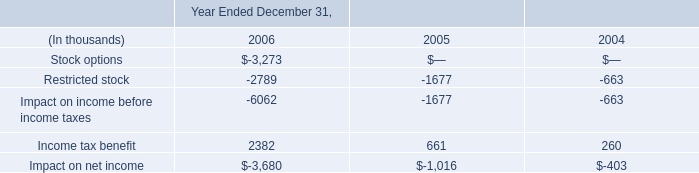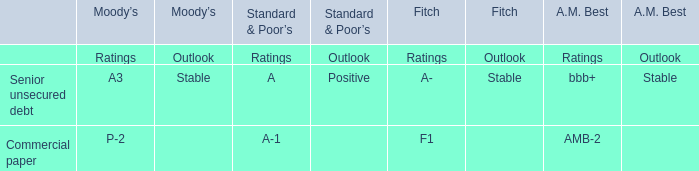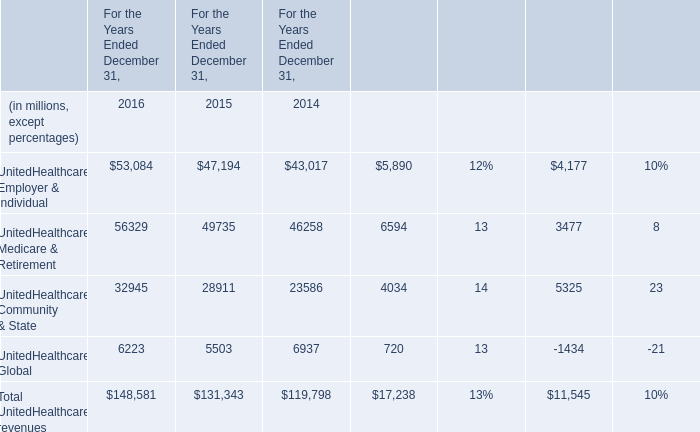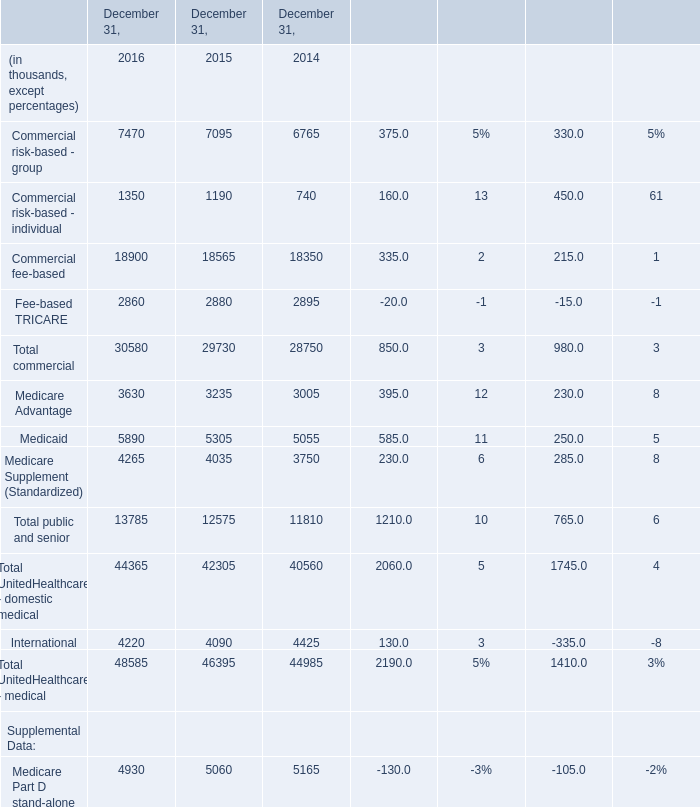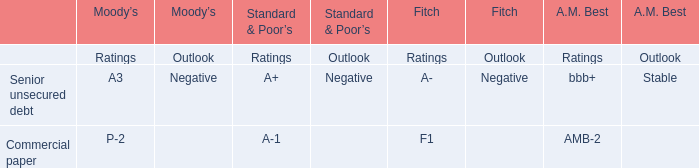What's the average of Restricted stock of Year Ended December 31, 2006, and Medicare Advantage of December 31, 2015 ? 
Computations: ((2789.0 + 3235.0) / 2)
Answer: 3012.0. 